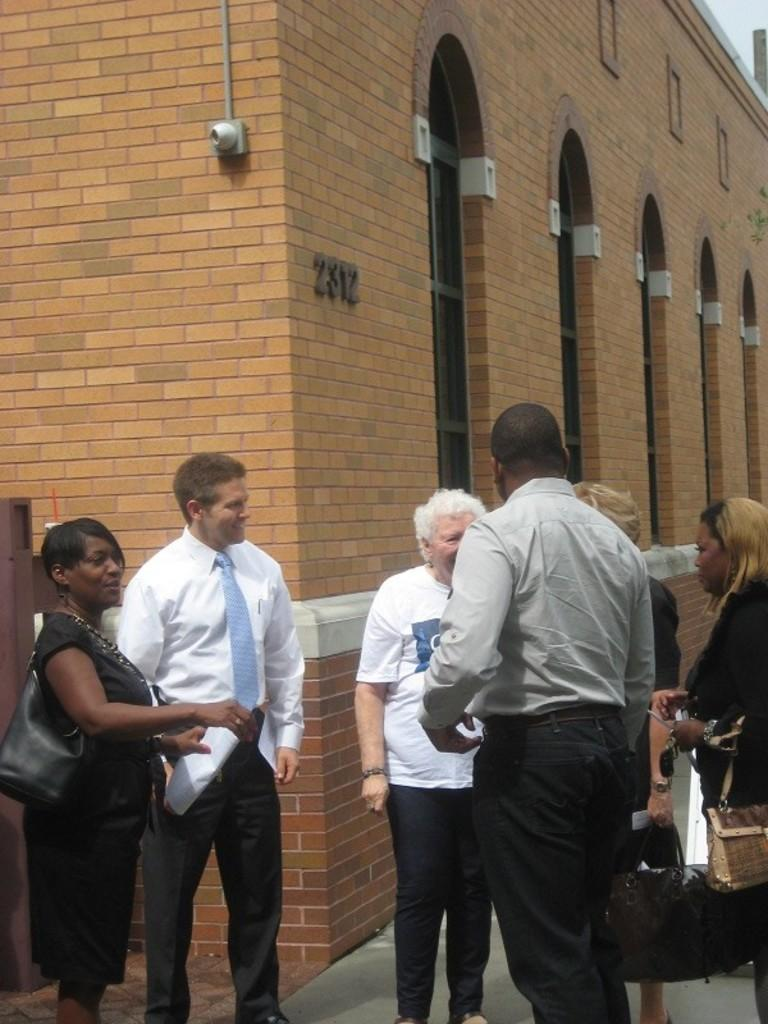What is happening in the image? There are people standing in the image, and they are talking to each other. What can be seen in the background of the image? There is a building in the background of the image. What type of bead is being used to decorate the ship in the image? There is no ship present in the image, and therefore no beads for decoration. 